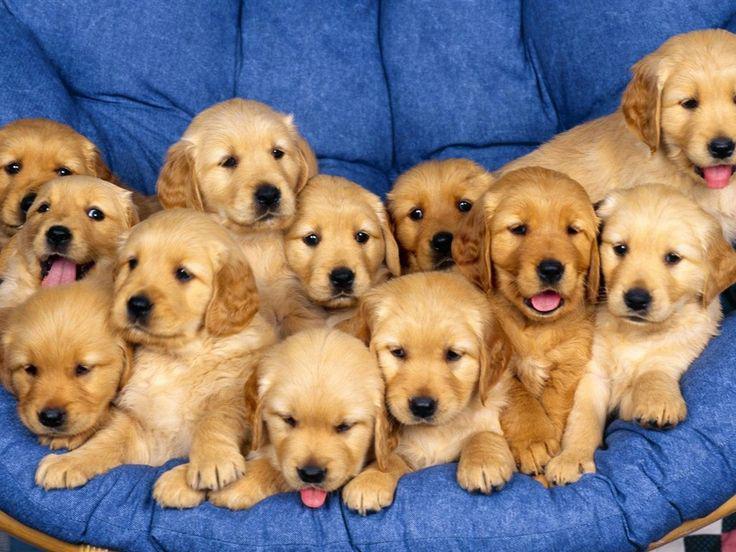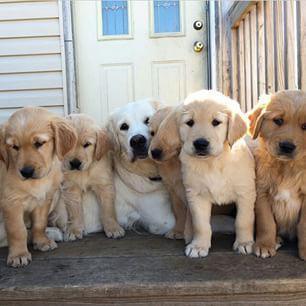The first image is the image on the left, the second image is the image on the right. Analyze the images presented: Is the assertion "One of the images in the pair contains at least ten dogs." valid? Answer yes or no. Yes. 